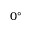Convert formula to latex. <formula><loc_0><loc_0><loc_500><loc_500>0 ^ { \circ }</formula> 